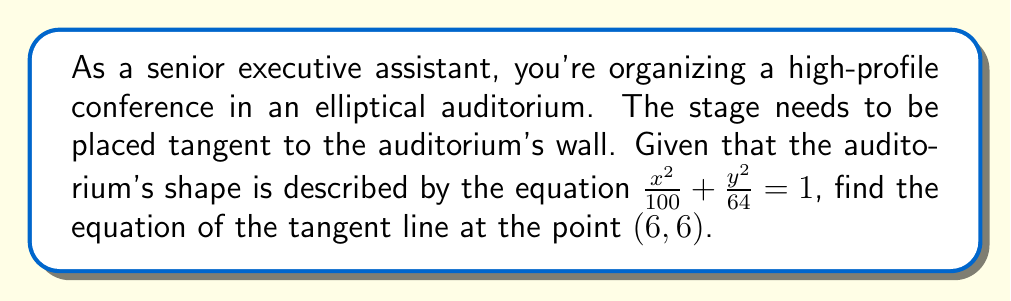Show me your answer to this math problem. Let's approach this step-by-step:

1) The general equation of an ellipse is $\frac{x^2}{a^2} + \frac{y^2}{b^2} = 1$. Here, $a^2 = 100$ and $b^2 = 64$.

2) The slope of the tangent line at any point $(x_0, y_0)$ on the ellipse is given by:

   $$m = -\frac{b^2x_0}{a^2y_0}$$

3) Substituting our values:
   
   $$m = -\frac{64 \cdot 6}{100 \cdot 6} = -\frac{64}{100} = -\frac{16}{25}$$

4) We can verify that (6, 6) is on the ellipse:

   $$\frac{6^2}{100} + \frac{6^2}{64} = \frac{36}{100} + \frac{36}{64} = 0.36 + 0.5625 = 0.9225 \approx 1$$

   (The slight difference is due to rounding)

5) Now we can use the point-slope form of a line: $y - y_0 = m(x - x_0)$

   Substituting our values:

   $$y - 6 = -\frac{16}{25}(x - 6)$$

6) Simplify to slope-intercept form:

   $$y = -\frac{16}{25}x + \frac{16}{25} \cdot 6 + 6$$
   $$y = -\frac{16}{25}x + \frac{96}{25} + \frac{150}{25}$$
   $$y = -\frac{16}{25}x + \frac{246}{25}$$
Answer: $y = -\frac{16}{25}x + \frac{246}{25}$ 